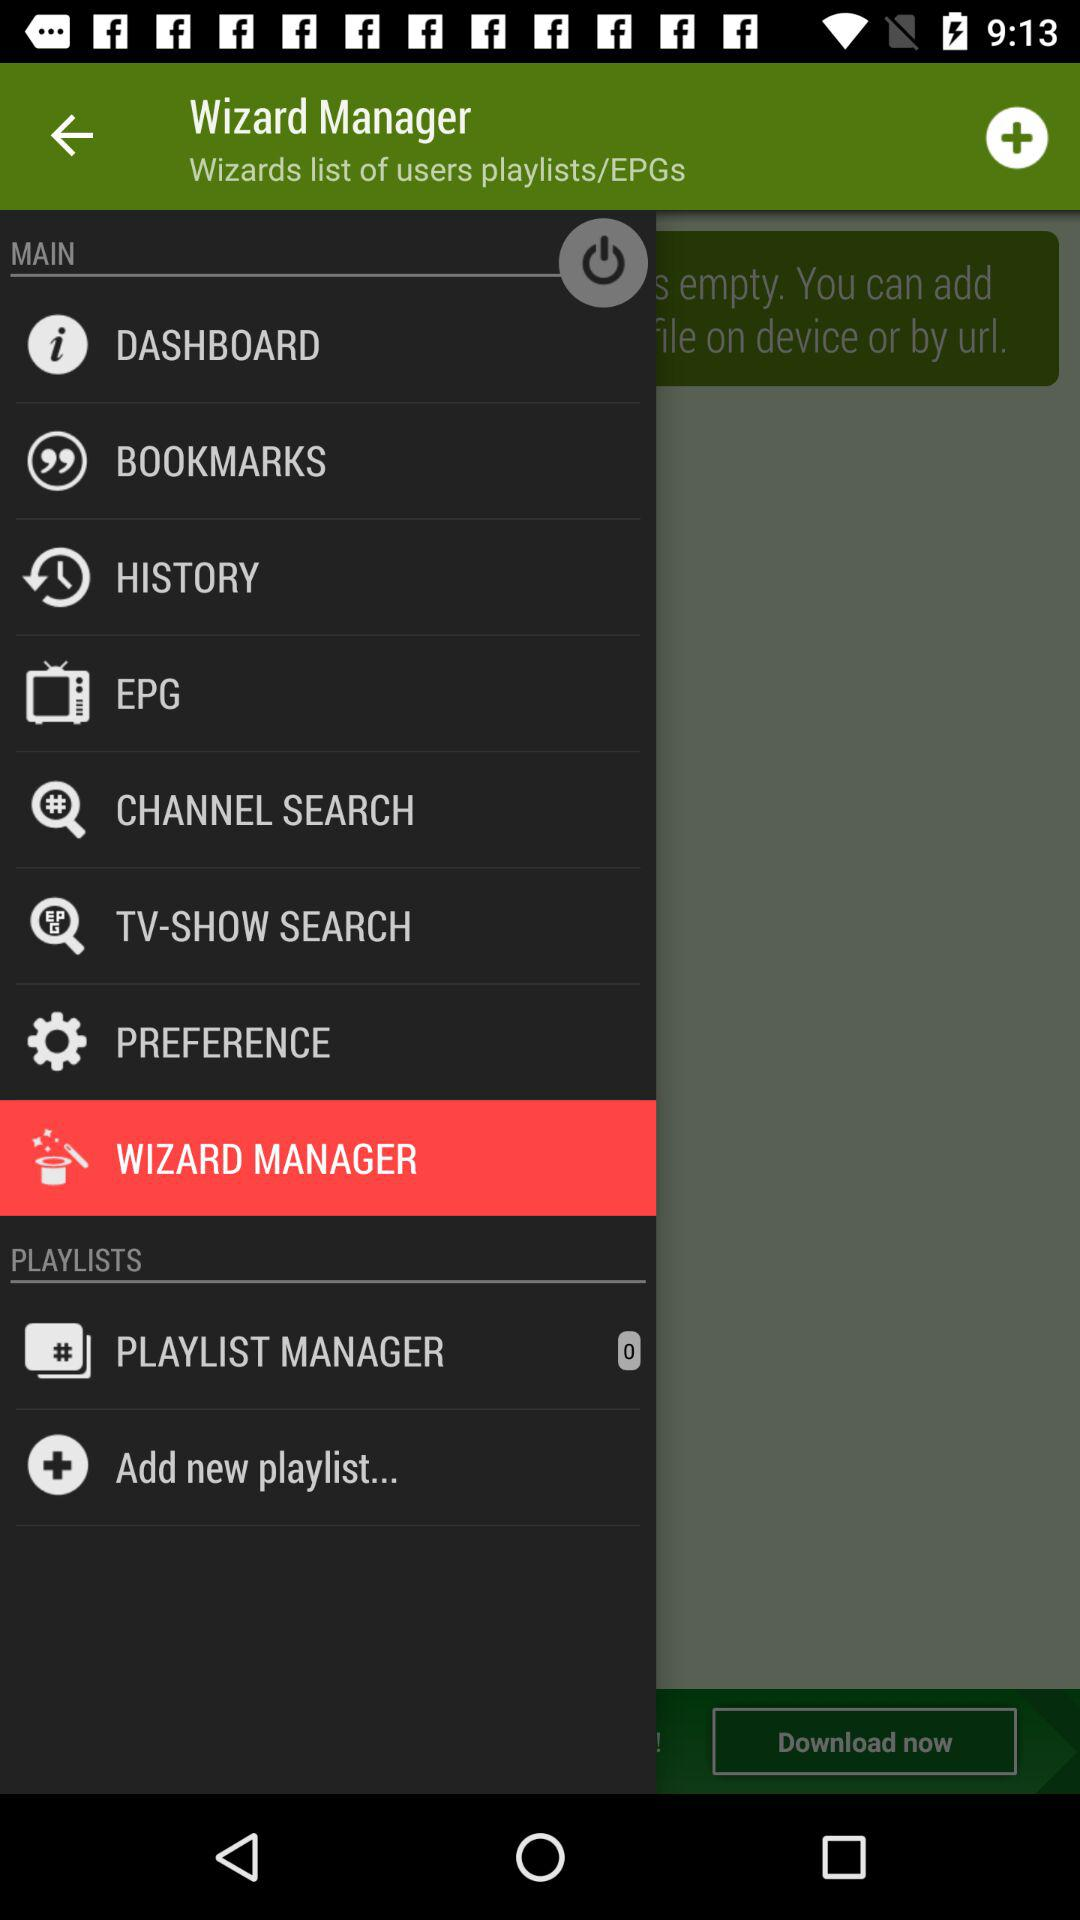What is the application name? The application name is "Wizard Manager". 